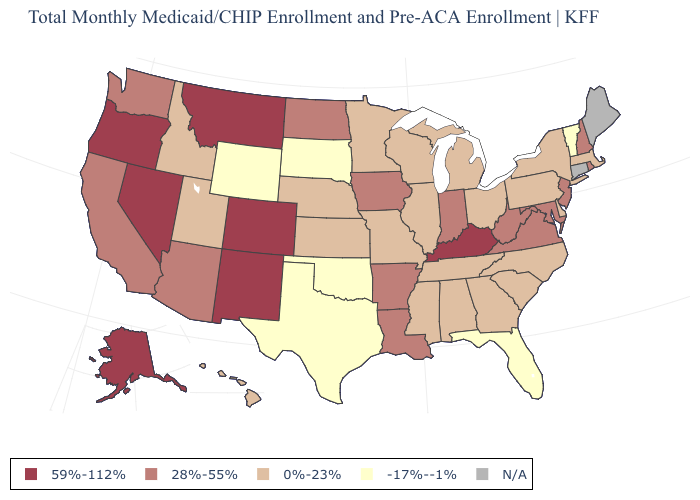What is the value of Minnesota?
Keep it brief. 0%-23%. What is the value of South Carolina?
Concise answer only. 0%-23%. Which states have the lowest value in the USA?
Short answer required. Florida, Oklahoma, South Dakota, Texas, Vermont, Wyoming. What is the lowest value in states that border Indiana?
Keep it brief. 0%-23%. What is the value of Wyoming?
Answer briefly. -17%--1%. What is the highest value in the MidWest ?
Write a very short answer. 28%-55%. Which states have the highest value in the USA?
Give a very brief answer. Alaska, Colorado, Kentucky, Montana, Nevada, New Mexico, Oregon. What is the highest value in the USA?
Keep it brief. 59%-112%. Name the states that have a value in the range 59%-112%?
Give a very brief answer. Alaska, Colorado, Kentucky, Montana, Nevada, New Mexico, Oregon. Among the states that border New York , does New Jersey have the highest value?
Give a very brief answer. Yes. What is the value of Arkansas?
Short answer required. 28%-55%. What is the lowest value in the Northeast?
Short answer required. -17%--1%. What is the value of Indiana?
Concise answer only. 28%-55%. Name the states that have a value in the range 0%-23%?
Be succinct. Alabama, Delaware, Georgia, Hawaii, Idaho, Illinois, Kansas, Massachusetts, Michigan, Minnesota, Mississippi, Missouri, Nebraska, New York, North Carolina, Ohio, Pennsylvania, South Carolina, Tennessee, Utah, Wisconsin. 